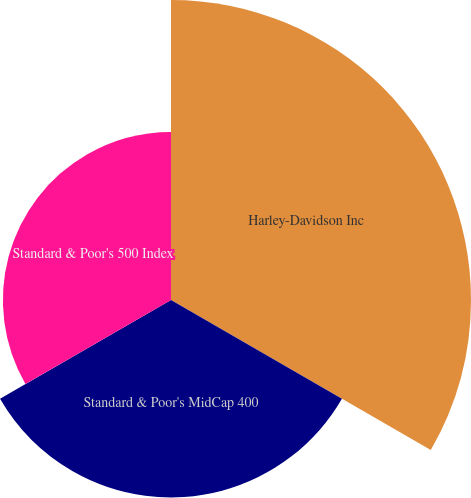Convert chart. <chart><loc_0><loc_0><loc_500><loc_500><pie_chart><fcel>Harley-Davidson Inc<fcel>Standard & Poor's MidCap 400<fcel>Standard & Poor's 500 Index<nl><fcel>45.08%<fcel>29.66%<fcel>25.26%<nl></chart> 